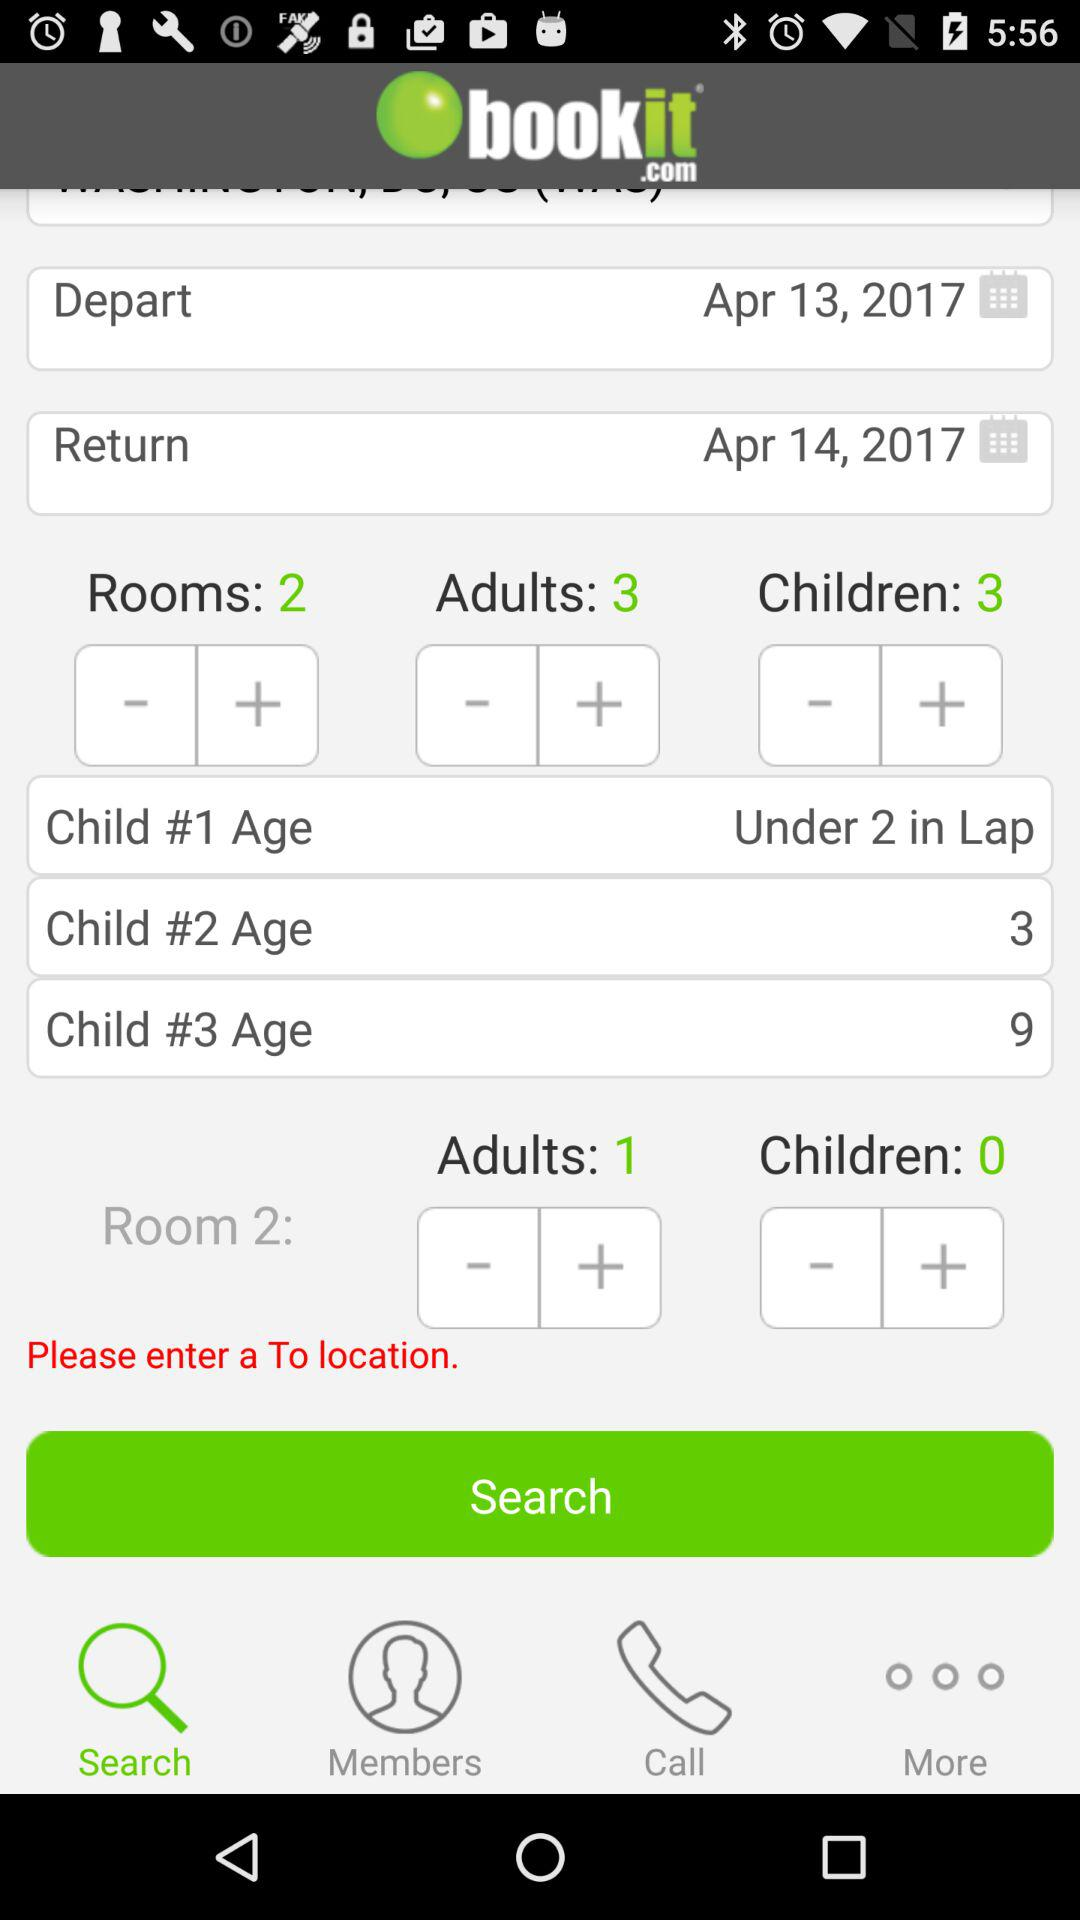Which tab am I on? You are on the "Search" tab. 